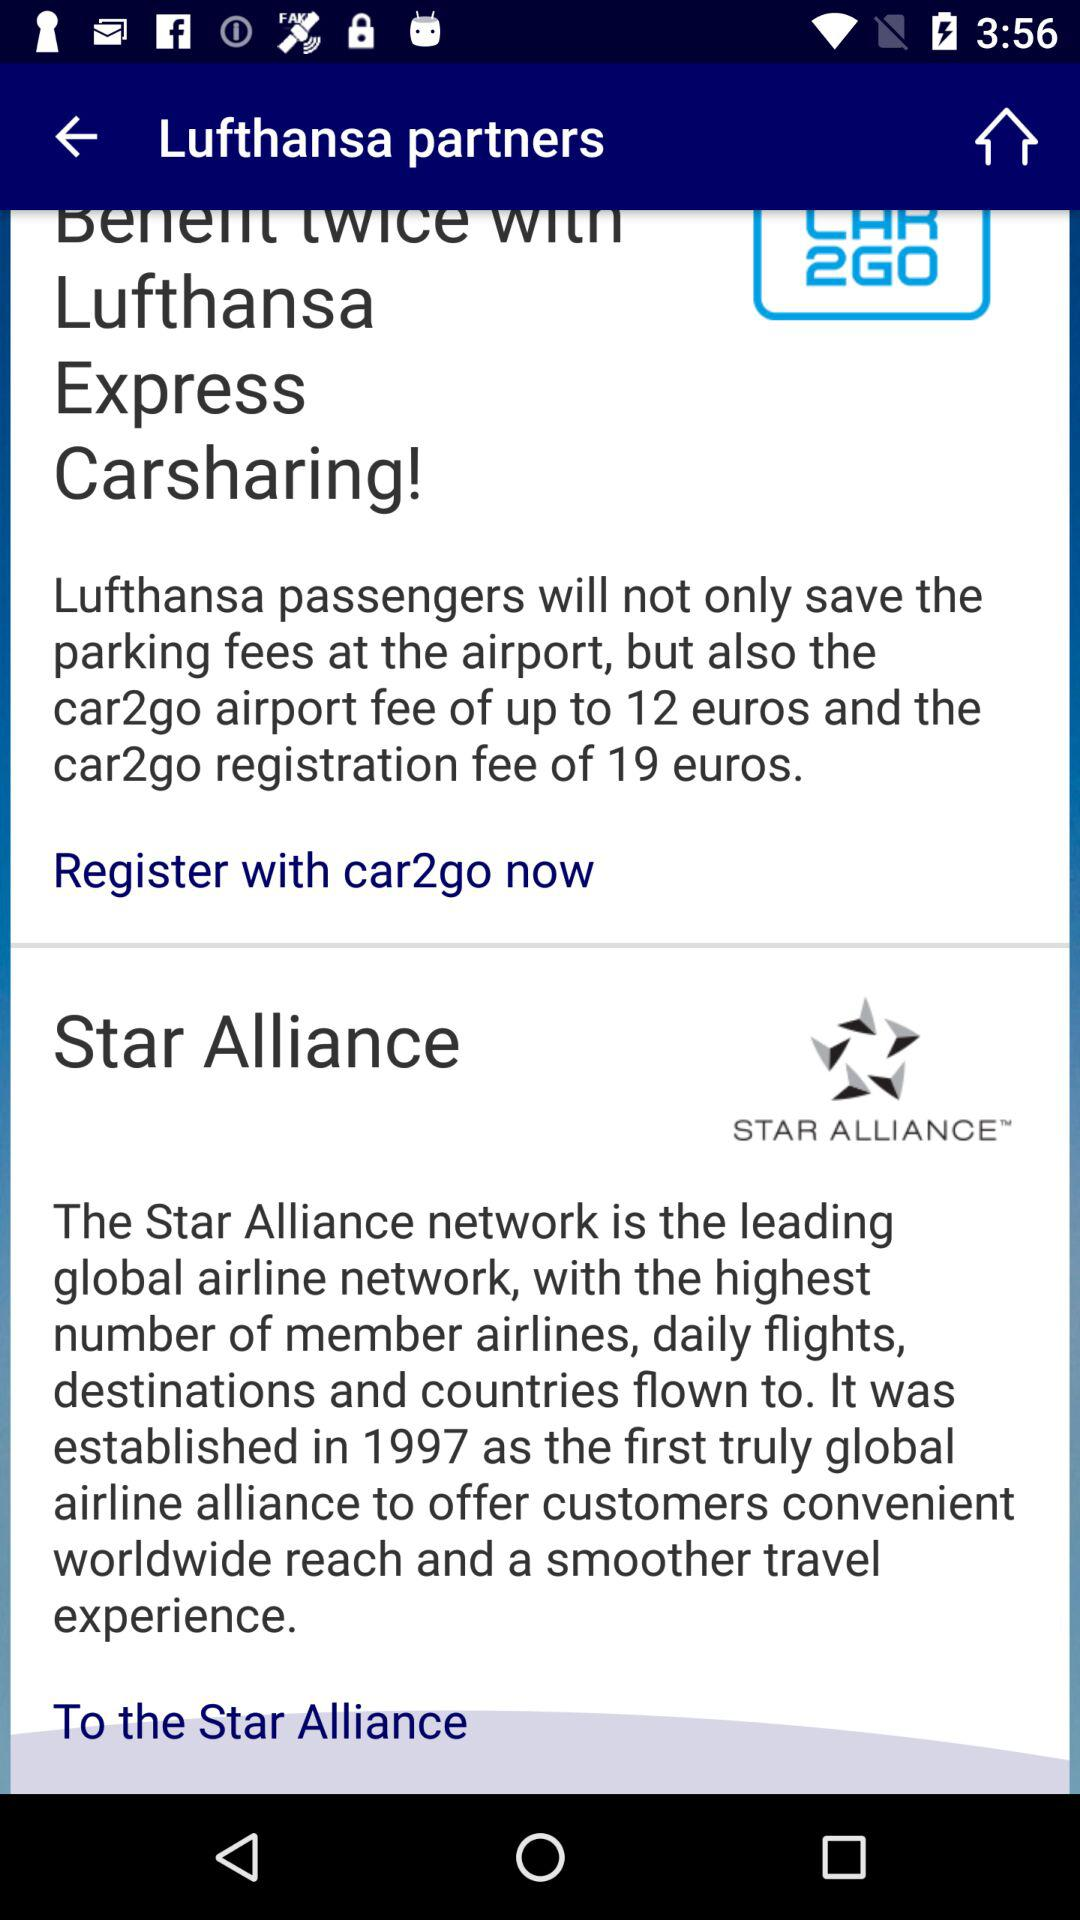Which fee amount is up to 12 euros? The fee is car2go airport fee. 